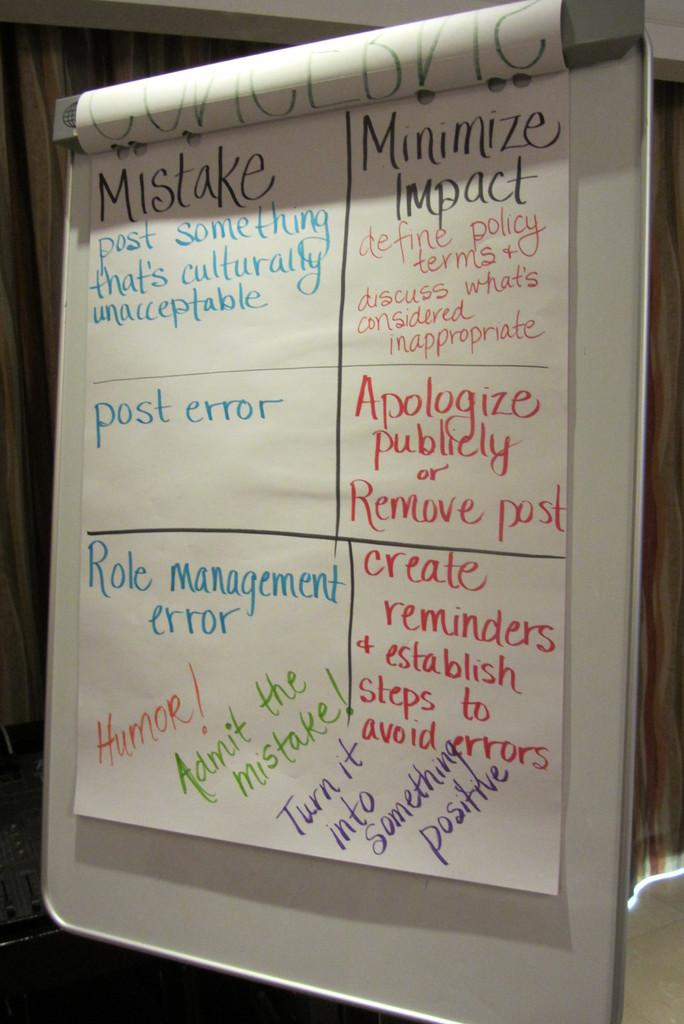<image>
Relay a brief, clear account of the picture shown. A poster describing proper procedures when an error happens. 